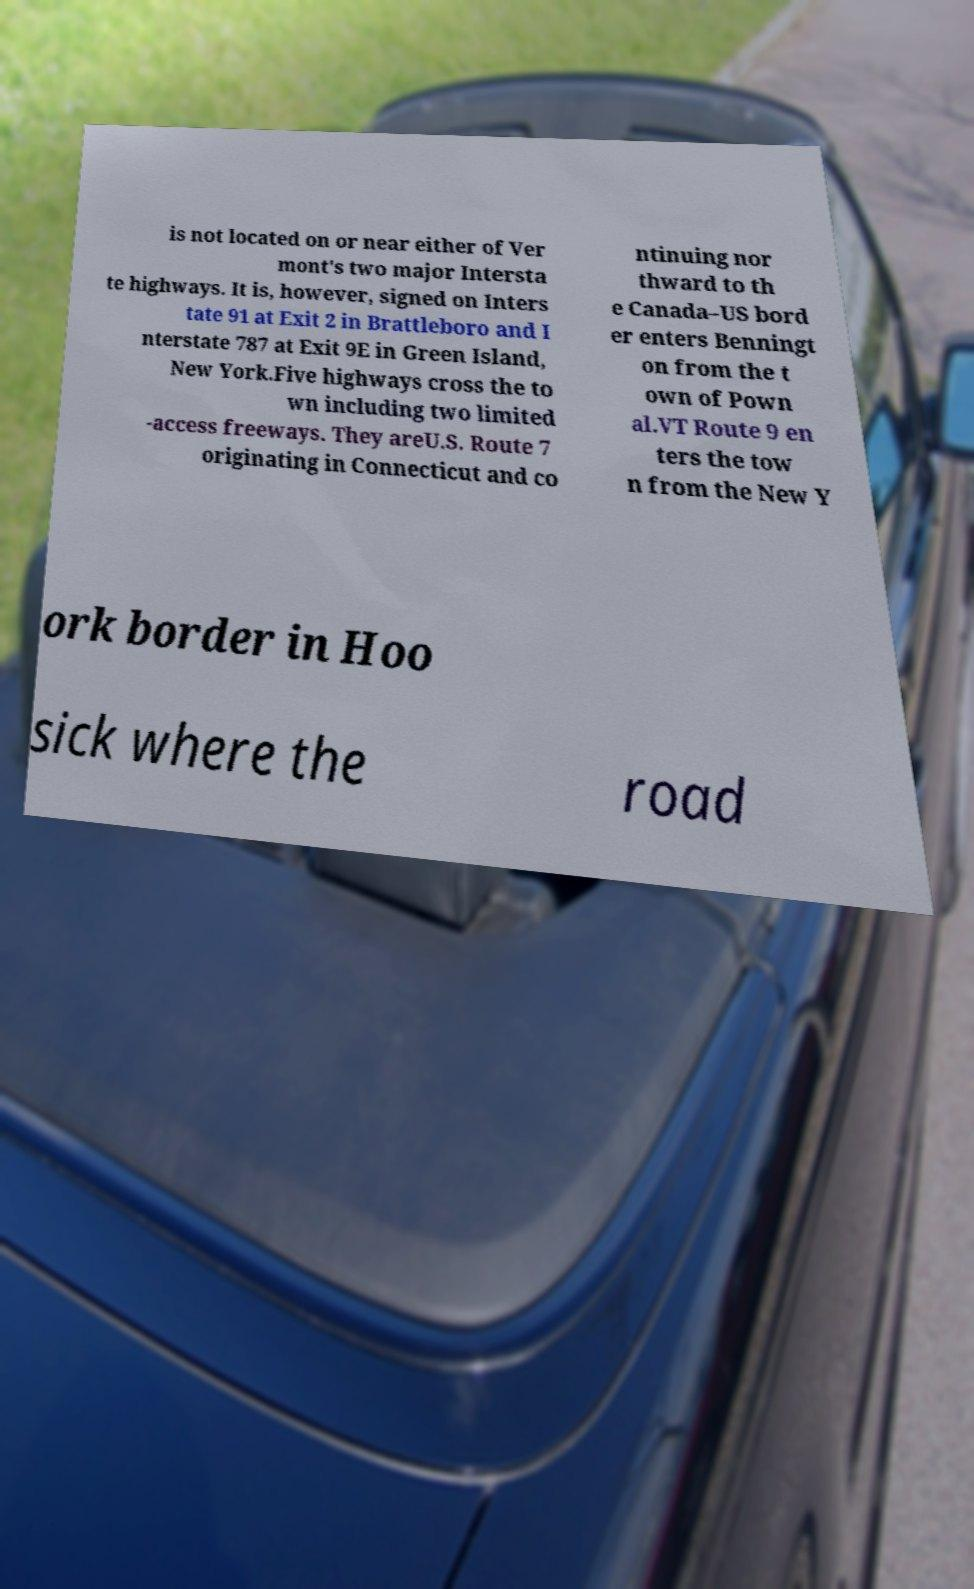Could you assist in decoding the text presented in this image and type it out clearly? is not located on or near either of Ver mont's two major Intersta te highways. It is, however, signed on Inters tate 91 at Exit 2 in Brattleboro and I nterstate 787 at Exit 9E in Green Island, New York.Five highways cross the to wn including two limited -access freeways. They areU.S. Route 7 originating in Connecticut and co ntinuing nor thward to th e Canada–US bord er enters Benningt on from the t own of Pown al.VT Route 9 en ters the tow n from the New Y ork border in Hoo sick where the road 